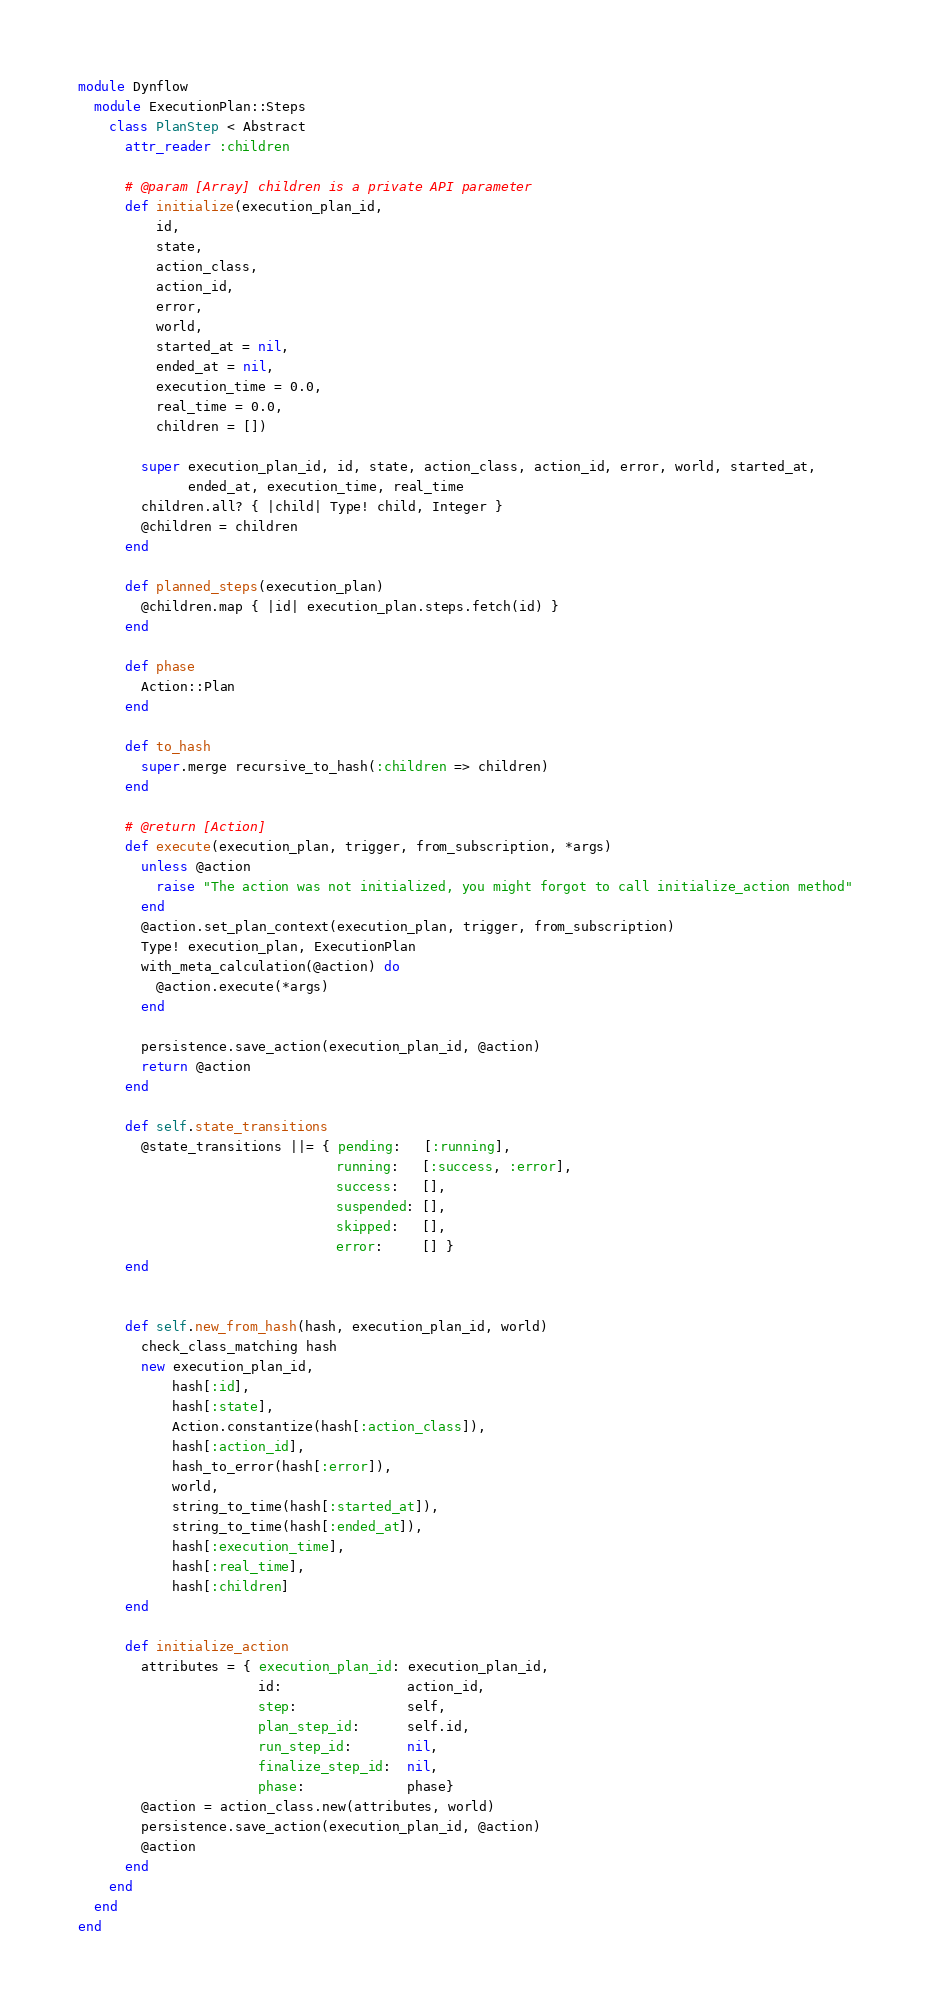Convert code to text. <code><loc_0><loc_0><loc_500><loc_500><_Ruby_>module Dynflow
  module ExecutionPlan::Steps
    class PlanStep < Abstract
      attr_reader :children

      # @param [Array] children is a private API parameter
      def initialize(execution_plan_id,
          id,
          state,
          action_class,
          action_id,
          error,
          world,
          started_at = nil,
          ended_at = nil,
          execution_time = 0.0,
          real_time = 0.0,
          children = [])

        super execution_plan_id, id, state, action_class, action_id, error, world, started_at,
              ended_at, execution_time, real_time
        children.all? { |child| Type! child, Integer }
        @children = children
      end

      def planned_steps(execution_plan)
        @children.map { |id| execution_plan.steps.fetch(id) }
      end

      def phase
        Action::Plan
      end

      def to_hash
        super.merge recursive_to_hash(:children => children)
      end

      # @return [Action]
      def execute(execution_plan, trigger, from_subscription, *args)
        unless @action
          raise "The action was not initialized, you might forgot to call initialize_action method"
        end
        @action.set_plan_context(execution_plan, trigger, from_subscription)
        Type! execution_plan, ExecutionPlan
        with_meta_calculation(@action) do
          @action.execute(*args)
        end

        persistence.save_action(execution_plan_id, @action)
        return @action
      end

      def self.state_transitions
        @state_transitions ||= { pending:   [:running],
                                 running:   [:success, :error],
                                 success:   [],
                                 suspended: [],
                                 skipped:   [],
                                 error:     [] }
      end


      def self.new_from_hash(hash, execution_plan_id, world)
        check_class_matching hash
        new execution_plan_id,
            hash[:id],
            hash[:state],
            Action.constantize(hash[:action_class]),
            hash[:action_id],
            hash_to_error(hash[:error]),
            world,
            string_to_time(hash[:started_at]),
            string_to_time(hash[:ended_at]),
            hash[:execution_time],
            hash[:real_time],
            hash[:children]
      end

      def initialize_action
        attributes = { execution_plan_id: execution_plan_id,
                       id:                action_id,
                       step:              self,
                       plan_step_id:      self.id,
                       run_step_id:       nil,
                       finalize_step_id:  nil,
                       phase:             phase}
        @action = action_class.new(attributes, world)
        persistence.save_action(execution_plan_id, @action)
        @action
      end
    end
  end
end
</code> 